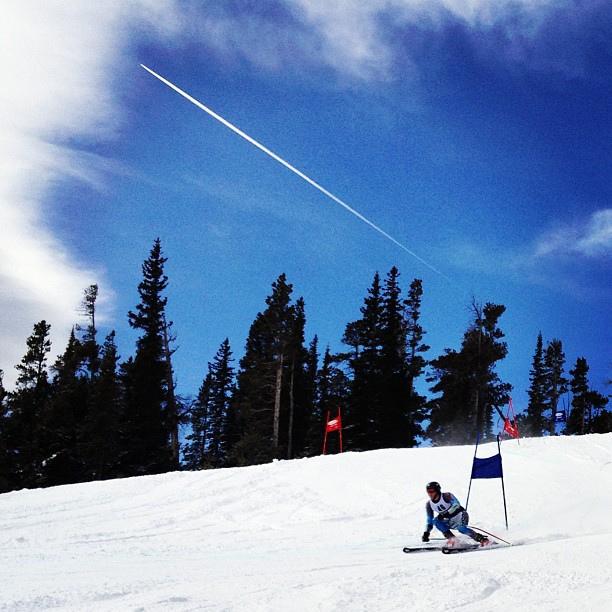Does the skier notice the airplane?
Answer briefly. No. Is there anything written in the sky?
Quick response, please. No. Does it look warm?
Write a very short answer. No. 